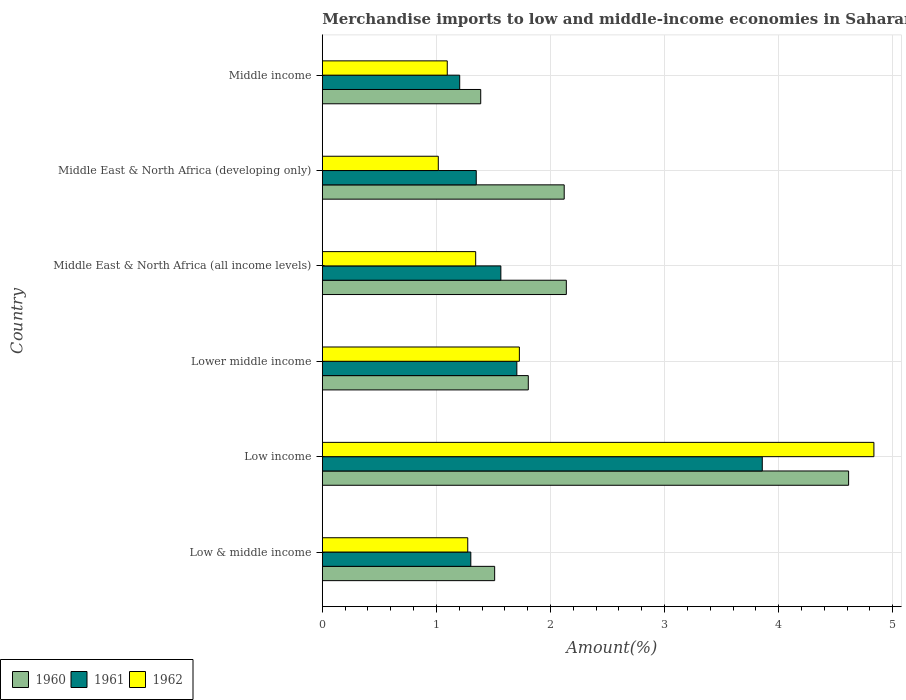How many different coloured bars are there?
Give a very brief answer. 3. Are the number of bars per tick equal to the number of legend labels?
Keep it short and to the point. Yes. Are the number of bars on each tick of the Y-axis equal?
Give a very brief answer. Yes. In how many cases, is the number of bars for a given country not equal to the number of legend labels?
Keep it short and to the point. 0. What is the percentage of amount earned from merchandise imports in 1961 in Middle East & North Africa (all income levels)?
Your answer should be compact. 1.57. Across all countries, what is the maximum percentage of amount earned from merchandise imports in 1962?
Keep it short and to the point. 4.84. Across all countries, what is the minimum percentage of amount earned from merchandise imports in 1962?
Offer a terse response. 1.02. What is the total percentage of amount earned from merchandise imports in 1962 in the graph?
Provide a short and direct response. 11.29. What is the difference between the percentage of amount earned from merchandise imports in 1962 in Middle East & North Africa (developing only) and that in Middle income?
Provide a short and direct response. -0.08. What is the difference between the percentage of amount earned from merchandise imports in 1962 in Low & middle income and the percentage of amount earned from merchandise imports in 1961 in Low income?
Keep it short and to the point. -2.58. What is the average percentage of amount earned from merchandise imports in 1962 per country?
Provide a succinct answer. 1.88. What is the difference between the percentage of amount earned from merchandise imports in 1961 and percentage of amount earned from merchandise imports in 1960 in Low & middle income?
Make the answer very short. -0.21. What is the ratio of the percentage of amount earned from merchandise imports in 1962 in Low income to that in Lower middle income?
Your response must be concise. 2.8. Is the percentage of amount earned from merchandise imports in 1960 in Middle East & North Africa (all income levels) less than that in Middle East & North Africa (developing only)?
Keep it short and to the point. No. Is the difference between the percentage of amount earned from merchandise imports in 1961 in Low & middle income and Low income greater than the difference between the percentage of amount earned from merchandise imports in 1960 in Low & middle income and Low income?
Offer a very short reply. Yes. What is the difference between the highest and the second highest percentage of amount earned from merchandise imports in 1962?
Provide a short and direct response. 3.11. What is the difference between the highest and the lowest percentage of amount earned from merchandise imports in 1962?
Your response must be concise. 3.82. What does the 3rd bar from the top in Middle East & North Africa (developing only) represents?
Give a very brief answer. 1960. What does the 2nd bar from the bottom in Middle East & North Africa (developing only) represents?
Your answer should be very brief. 1961. Is it the case that in every country, the sum of the percentage of amount earned from merchandise imports in 1962 and percentage of amount earned from merchandise imports in 1961 is greater than the percentage of amount earned from merchandise imports in 1960?
Your response must be concise. Yes. How many bars are there?
Keep it short and to the point. 18. Are all the bars in the graph horizontal?
Your answer should be compact. Yes. Does the graph contain grids?
Your answer should be compact. Yes. Where does the legend appear in the graph?
Give a very brief answer. Bottom left. How are the legend labels stacked?
Provide a short and direct response. Horizontal. What is the title of the graph?
Give a very brief answer. Merchandise imports to low and middle-income economies in Saharan Africa. Does "1999" appear as one of the legend labels in the graph?
Your answer should be compact. No. What is the label or title of the X-axis?
Give a very brief answer. Amount(%). What is the Amount(%) of 1960 in Low & middle income?
Your response must be concise. 1.51. What is the Amount(%) of 1961 in Low & middle income?
Your answer should be very brief. 1.3. What is the Amount(%) of 1962 in Low & middle income?
Offer a very short reply. 1.27. What is the Amount(%) in 1960 in Low income?
Offer a terse response. 4.61. What is the Amount(%) of 1961 in Low income?
Keep it short and to the point. 3.86. What is the Amount(%) in 1962 in Low income?
Provide a succinct answer. 4.84. What is the Amount(%) of 1960 in Lower middle income?
Your response must be concise. 1.81. What is the Amount(%) of 1961 in Lower middle income?
Keep it short and to the point. 1.71. What is the Amount(%) of 1962 in Lower middle income?
Your answer should be very brief. 1.73. What is the Amount(%) in 1960 in Middle East & North Africa (all income levels)?
Provide a short and direct response. 2.14. What is the Amount(%) in 1961 in Middle East & North Africa (all income levels)?
Make the answer very short. 1.57. What is the Amount(%) of 1962 in Middle East & North Africa (all income levels)?
Your answer should be compact. 1.34. What is the Amount(%) of 1960 in Middle East & North Africa (developing only)?
Give a very brief answer. 2.12. What is the Amount(%) in 1961 in Middle East & North Africa (developing only)?
Make the answer very short. 1.35. What is the Amount(%) of 1962 in Middle East & North Africa (developing only)?
Ensure brevity in your answer.  1.02. What is the Amount(%) of 1960 in Middle income?
Your response must be concise. 1.39. What is the Amount(%) in 1961 in Middle income?
Keep it short and to the point. 1.2. What is the Amount(%) in 1962 in Middle income?
Provide a short and direct response. 1.1. Across all countries, what is the maximum Amount(%) of 1960?
Offer a very short reply. 4.61. Across all countries, what is the maximum Amount(%) in 1961?
Make the answer very short. 3.86. Across all countries, what is the maximum Amount(%) in 1962?
Make the answer very short. 4.84. Across all countries, what is the minimum Amount(%) of 1960?
Keep it short and to the point. 1.39. Across all countries, what is the minimum Amount(%) of 1961?
Offer a terse response. 1.2. Across all countries, what is the minimum Amount(%) of 1962?
Give a very brief answer. 1.02. What is the total Amount(%) of 1960 in the graph?
Your answer should be compact. 13.58. What is the total Amount(%) of 1961 in the graph?
Your answer should be compact. 10.98. What is the total Amount(%) of 1962 in the graph?
Make the answer very short. 11.29. What is the difference between the Amount(%) of 1960 in Low & middle income and that in Low income?
Make the answer very short. -3.1. What is the difference between the Amount(%) of 1961 in Low & middle income and that in Low income?
Offer a terse response. -2.56. What is the difference between the Amount(%) of 1962 in Low & middle income and that in Low income?
Provide a succinct answer. -3.56. What is the difference between the Amount(%) in 1960 in Low & middle income and that in Lower middle income?
Keep it short and to the point. -0.29. What is the difference between the Amount(%) in 1961 in Low & middle income and that in Lower middle income?
Offer a terse response. -0.4. What is the difference between the Amount(%) of 1962 in Low & middle income and that in Lower middle income?
Give a very brief answer. -0.45. What is the difference between the Amount(%) in 1960 in Low & middle income and that in Middle East & North Africa (all income levels)?
Your answer should be very brief. -0.63. What is the difference between the Amount(%) in 1961 in Low & middle income and that in Middle East & North Africa (all income levels)?
Ensure brevity in your answer.  -0.26. What is the difference between the Amount(%) in 1962 in Low & middle income and that in Middle East & North Africa (all income levels)?
Provide a succinct answer. -0.07. What is the difference between the Amount(%) of 1960 in Low & middle income and that in Middle East & North Africa (developing only)?
Ensure brevity in your answer.  -0.61. What is the difference between the Amount(%) of 1961 in Low & middle income and that in Middle East & North Africa (developing only)?
Offer a terse response. -0.05. What is the difference between the Amount(%) of 1962 in Low & middle income and that in Middle East & North Africa (developing only)?
Provide a succinct answer. 0.26. What is the difference between the Amount(%) of 1960 in Low & middle income and that in Middle income?
Ensure brevity in your answer.  0.12. What is the difference between the Amount(%) of 1961 in Low & middle income and that in Middle income?
Give a very brief answer. 0.1. What is the difference between the Amount(%) of 1962 in Low & middle income and that in Middle income?
Keep it short and to the point. 0.18. What is the difference between the Amount(%) of 1960 in Low income and that in Lower middle income?
Offer a terse response. 2.81. What is the difference between the Amount(%) of 1961 in Low income and that in Lower middle income?
Offer a very short reply. 2.15. What is the difference between the Amount(%) in 1962 in Low income and that in Lower middle income?
Make the answer very short. 3.11. What is the difference between the Amount(%) in 1960 in Low income and that in Middle East & North Africa (all income levels)?
Provide a succinct answer. 2.47. What is the difference between the Amount(%) in 1961 in Low income and that in Middle East & North Africa (all income levels)?
Your answer should be very brief. 2.29. What is the difference between the Amount(%) of 1962 in Low income and that in Middle East & North Africa (all income levels)?
Your answer should be very brief. 3.49. What is the difference between the Amount(%) of 1960 in Low income and that in Middle East & North Africa (developing only)?
Your answer should be compact. 2.49. What is the difference between the Amount(%) of 1961 in Low income and that in Middle East & North Africa (developing only)?
Your response must be concise. 2.51. What is the difference between the Amount(%) of 1962 in Low income and that in Middle East & North Africa (developing only)?
Your response must be concise. 3.82. What is the difference between the Amount(%) in 1960 in Low income and that in Middle income?
Ensure brevity in your answer.  3.23. What is the difference between the Amount(%) in 1961 in Low income and that in Middle income?
Your answer should be compact. 2.65. What is the difference between the Amount(%) of 1962 in Low income and that in Middle income?
Give a very brief answer. 3.74. What is the difference between the Amount(%) of 1960 in Lower middle income and that in Middle East & North Africa (all income levels)?
Provide a short and direct response. -0.33. What is the difference between the Amount(%) in 1961 in Lower middle income and that in Middle East & North Africa (all income levels)?
Provide a succinct answer. 0.14. What is the difference between the Amount(%) of 1962 in Lower middle income and that in Middle East & North Africa (all income levels)?
Your answer should be compact. 0.38. What is the difference between the Amount(%) in 1960 in Lower middle income and that in Middle East & North Africa (developing only)?
Ensure brevity in your answer.  -0.31. What is the difference between the Amount(%) in 1961 in Lower middle income and that in Middle East & North Africa (developing only)?
Keep it short and to the point. 0.36. What is the difference between the Amount(%) of 1962 in Lower middle income and that in Middle East & North Africa (developing only)?
Keep it short and to the point. 0.71. What is the difference between the Amount(%) of 1960 in Lower middle income and that in Middle income?
Your answer should be compact. 0.42. What is the difference between the Amount(%) of 1961 in Lower middle income and that in Middle income?
Provide a short and direct response. 0.5. What is the difference between the Amount(%) of 1962 in Lower middle income and that in Middle income?
Give a very brief answer. 0.63. What is the difference between the Amount(%) of 1960 in Middle East & North Africa (all income levels) and that in Middle East & North Africa (developing only)?
Your answer should be very brief. 0.02. What is the difference between the Amount(%) in 1961 in Middle East & North Africa (all income levels) and that in Middle East & North Africa (developing only)?
Ensure brevity in your answer.  0.22. What is the difference between the Amount(%) of 1962 in Middle East & North Africa (all income levels) and that in Middle East & North Africa (developing only)?
Make the answer very short. 0.33. What is the difference between the Amount(%) in 1960 in Middle East & North Africa (all income levels) and that in Middle income?
Keep it short and to the point. 0.75. What is the difference between the Amount(%) in 1961 in Middle East & North Africa (all income levels) and that in Middle income?
Make the answer very short. 0.36. What is the difference between the Amount(%) in 1962 in Middle East & North Africa (all income levels) and that in Middle income?
Your answer should be compact. 0.25. What is the difference between the Amount(%) of 1960 in Middle East & North Africa (developing only) and that in Middle income?
Keep it short and to the point. 0.73. What is the difference between the Amount(%) in 1961 in Middle East & North Africa (developing only) and that in Middle income?
Ensure brevity in your answer.  0.15. What is the difference between the Amount(%) of 1962 in Middle East & North Africa (developing only) and that in Middle income?
Your answer should be compact. -0.08. What is the difference between the Amount(%) in 1960 in Low & middle income and the Amount(%) in 1961 in Low income?
Provide a succinct answer. -2.35. What is the difference between the Amount(%) in 1960 in Low & middle income and the Amount(%) in 1962 in Low income?
Offer a very short reply. -3.32. What is the difference between the Amount(%) of 1961 in Low & middle income and the Amount(%) of 1962 in Low income?
Offer a terse response. -3.53. What is the difference between the Amount(%) of 1960 in Low & middle income and the Amount(%) of 1961 in Lower middle income?
Give a very brief answer. -0.19. What is the difference between the Amount(%) of 1960 in Low & middle income and the Amount(%) of 1962 in Lower middle income?
Give a very brief answer. -0.22. What is the difference between the Amount(%) of 1961 in Low & middle income and the Amount(%) of 1962 in Lower middle income?
Your answer should be very brief. -0.43. What is the difference between the Amount(%) in 1960 in Low & middle income and the Amount(%) in 1961 in Middle East & North Africa (all income levels)?
Provide a short and direct response. -0.05. What is the difference between the Amount(%) in 1960 in Low & middle income and the Amount(%) in 1962 in Middle East & North Africa (all income levels)?
Keep it short and to the point. 0.17. What is the difference between the Amount(%) in 1961 in Low & middle income and the Amount(%) in 1962 in Middle East & North Africa (all income levels)?
Offer a terse response. -0.04. What is the difference between the Amount(%) of 1960 in Low & middle income and the Amount(%) of 1961 in Middle East & North Africa (developing only)?
Provide a succinct answer. 0.16. What is the difference between the Amount(%) in 1960 in Low & middle income and the Amount(%) in 1962 in Middle East & North Africa (developing only)?
Make the answer very short. 0.49. What is the difference between the Amount(%) of 1961 in Low & middle income and the Amount(%) of 1962 in Middle East & North Africa (developing only)?
Offer a terse response. 0.29. What is the difference between the Amount(%) in 1960 in Low & middle income and the Amount(%) in 1961 in Middle income?
Keep it short and to the point. 0.31. What is the difference between the Amount(%) of 1960 in Low & middle income and the Amount(%) of 1962 in Middle income?
Your answer should be very brief. 0.42. What is the difference between the Amount(%) of 1961 in Low & middle income and the Amount(%) of 1962 in Middle income?
Your answer should be compact. 0.21. What is the difference between the Amount(%) in 1960 in Low income and the Amount(%) in 1961 in Lower middle income?
Ensure brevity in your answer.  2.91. What is the difference between the Amount(%) in 1960 in Low income and the Amount(%) in 1962 in Lower middle income?
Provide a succinct answer. 2.89. What is the difference between the Amount(%) in 1961 in Low income and the Amount(%) in 1962 in Lower middle income?
Your response must be concise. 2.13. What is the difference between the Amount(%) of 1960 in Low income and the Amount(%) of 1961 in Middle East & North Africa (all income levels)?
Ensure brevity in your answer.  3.05. What is the difference between the Amount(%) in 1960 in Low income and the Amount(%) in 1962 in Middle East & North Africa (all income levels)?
Offer a very short reply. 3.27. What is the difference between the Amount(%) of 1961 in Low income and the Amount(%) of 1962 in Middle East & North Africa (all income levels)?
Ensure brevity in your answer.  2.51. What is the difference between the Amount(%) in 1960 in Low income and the Amount(%) in 1961 in Middle East & North Africa (developing only)?
Provide a short and direct response. 3.26. What is the difference between the Amount(%) of 1960 in Low income and the Amount(%) of 1962 in Middle East & North Africa (developing only)?
Keep it short and to the point. 3.6. What is the difference between the Amount(%) in 1961 in Low income and the Amount(%) in 1962 in Middle East & North Africa (developing only)?
Provide a short and direct response. 2.84. What is the difference between the Amount(%) in 1960 in Low income and the Amount(%) in 1961 in Middle income?
Your response must be concise. 3.41. What is the difference between the Amount(%) of 1960 in Low income and the Amount(%) of 1962 in Middle income?
Provide a short and direct response. 3.52. What is the difference between the Amount(%) of 1961 in Low income and the Amount(%) of 1962 in Middle income?
Offer a very short reply. 2.76. What is the difference between the Amount(%) of 1960 in Lower middle income and the Amount(%) of 1961 in Middle East & North Africa (all income levels)?
Offer a terse response. 0.24. What is the difference between the Amount(%) of 1960 in Lower middle income and the Amount(%) of 1962 in Middle East & North Africa (all income levels)?
Keep it short and to the point. 0.46. What is the difference between the Amount(%) of 1961 in Lower middle income and the Amount(%) of 1962 in Middle East & North Africa (all income levels)?
Ensure brevity in your answer.  0.36. What is the difference between the Amount(%) in 1960 in Lower middle income and the Amount(%) in 1961 in Middle East & North Africa (developing only)?
Provide a succinct answer. 0.46. What is the difference between the Amount(%) in 1960 in Lower middle income and the Amount(%) in 1962 in Middle East & North Africa (developing only)?
Provide a succinct answer. 0.79. What is the difference between the Amount(%) of 1961 in Lower middle income and the Amount(%) of 1962 in Middle East & North Africa (developing only)?
Offer a very short reply. 0.69. What is the difference between the Amount(%) of 1960 in Lower middle income and the Amount(%) of 1961 in Middle income?
Give a very brief answer. 0.6. What is the difference between the Amount(%) in 1960 in Lower middle income and the Amount(%) in 1962 in Middle income?
Provide a short and direct response. 0.71. What is the difference between the Amount(%) of 1961 in Lower middle income and the Amount(%) of 1962 in Middle income?
Offer a very short reply. 0.61. What is the difference between the Amount(%) in 1960 in Middle East & North Africa (all income levels) and the Amount(%) in 1961 in Middle East & North Africa (developing only)?
Give a very brief answer. 0.79. What is the difference between the Amount(%) of 1960 in Middle East & North Africa (all income levels) and the Amount(%) of 1962 in Middle East & North Africa (developing only)?
Your answer should be very brief. 1.12. What is the difference between the Amount(%) in 1961 in Middle East & North Africa (all income levels) and the Amount(%) in 1962 in Middle East & North Africa (developing only)?
Offer a very short reply. 0.55. What is the difference between the Amount(%) of 1960 in Middle East & North Africa (all income levels) and the Amount(%) of 1961 in Middle income?
Your response must be concise. 0.93. What is the difference between the Amount(%) of 1960 in Middle East & North Africa (all income levels) and the Amount(%) of 1962 in Middle income?
Your answer should be compact. 1.04. What is the difference between the Amount(%) in 1961 in Middle East & North Africa (all income levels) and the Amount(%) in 1962 in Middle income?
Your answer should be very brief. 0.47. What is the difference between the Amount(%) of 1960 in Middle East & North Africa (developing only) and the Amount(%) of 1961 in Middle income?
Ensure brevity in your answer.  0.92. What is the difference between the Amount(%) in 1960 in Middle East & North Africa (developing only) and the Amount(%) in 1962 in Middle income?
Ensure brevity in your answer.  1.03. What is the difference between the Amount(%) of 1961 in Middle East & North Africa (developing only) and the Amount(%) of 1962 in Middle income?
Provide a succinct answer. 0.25. What is the average Amount(%) in 1960 per country?
Give a very brief answer. 2.26. What is the average Amount(%) in 1961 per country?
Provide a short and direct response. 1.83. What is the average Amount(%) in 1962 per country?
Offer a very short reply. 1.88. What is the difference between the Amount(%) in 1960 and Amount(%) in 1961 in Low & middle income?
Make the answer very short. 0.21. What is the difference between the Amount(%) in 1960 and Amount(%) in 1962 in Low & middle income?
Your answer should be very brief. 0.24. What is the difference between the Amount(%) in 1961 and Amount(%) in 1962 in Low & middle income?
Your answer should be compact. 0.03. What is the difference between the Amount(%) in 1960 and Amount(%) in 1961 in Low income?
Make the answer very short. 0.76. What is the difference between the Amount(%) of 1960 and Amount(%) of 1962 in Low income?
Ensure brevity in your answer.  -0.22. What is the difference between the Amount(%) of 1961 and Amount(%) of 1962 in Low income?
Make the answer very short. -0.98. What is the difference between the Amount(%) of 1960 and Amount(%) of 1961 in Lower middle income?
Make the answer very short. 0.1. What is the difference between the Amount(%) of 1960 and Amount(%) of 1962 in Lower middle income?
Your response must be concise. 0.08. What is the difference between the Amount(%) of 1961 and Amount(%) of 1962 in Lower middle income?
Ensure brevity in your answer.  -0.02. What is the difference between the Amount(%) of 1960 and Amount(%) of 1961 in Middle East & North Africa (all income levels)?
Give a very brief answer. 0.57. What is the difference between the Amount(%) in 1960 and Amount(%) in 1962 in Middle East & North Africa (all income levels)?
Provide a short and direct response. 0.79. What is the difference between the Amount(%) in 1961 and Amount(%) in 1962 in Middle East & North Africa (all income levels)?
Give a very brief answer. 0.22. What is the difference between the Amount(%) of 1960 and Amount(%) of 1961 in Middle East & North Africa (developing only)?
Provide a short and direct response. 0.77. What is the difference between the Amount(%) in 1960 and Amount(%) in 1962 in Middle East & North Africa (developing only)?
Your answer should be compact. 1.1. What is the difference between the Amount(%) of 1961 and Amount(%) of 1962 in Middle East & North Africa (developing only)?
Give a very brief answer. 0.33. What is the difference between the Amount(%) in 1960 and Amount(%) in 1961 in Middle income?
Your answer should be compact. 0.18. What is the difference between the Amount(%) of 1960 and Amount(%) of 1962 in Middle income?
Provide a succinct answer. 0.29. What is the difference between the Amount(%) of 1961 and Amount(%) of 1962 in Middle income?
Offer a terse response. 0.11. What is the ratio of the Amount(%) in 1960 in Low & middle income to that in Low income?
Keep it short and to the point. 0.33. What is the ratio of the Amount(%) in 1961 in Low & middle income to that in Low income?
Your answer should be compact. 0.34. What is the ratio of the Amount(%) in 1962 in Low & middle income to that in Low income?
Make the answer very short. 0.26. What is the ratio of the Amount(%) in 1960 in Low & middle income to that in Lower middle income?
Your response must be concise. 0.84. What is the ratio of the Amount(%) of 1961 in Low & middle income to that in Lower middle income?
Ensure brevity in your answer.  0.76. What is the ratio of the Amount(%) of 1962 in Low & middle income to that in Lower middle income?
Your answer should be very brief. 0.74. What is the ratio of the Amount(%) of 1960 in Low & middle income to that in Middle East & North Africa (all income levels)?
Your answer should be compact. 0.71. What is the ratio of the Amount(%) of 1961 in Low & middle income to that in Middle East & North Africa (all income levels)?
Offer a terse response. 0.83. What is the ratio of the Amount(%) in 1962 in Low & middle income to that in Middle East & North Africa (all income levels)?
Ensure brevity in your answer.  0.95. What is the ratio of the Amount(%) of 1960 in Low & middle income to that in Middle East & North Africa (developing only)?
Provide a succinct answer. 0.71. What is the ratio of the Amount(%) in 1961 in Low & middle income to that in Middle East & North Africa (developing only)?
Ensure brevity in your answer.  0.96. What is the ratio of the Amount(%) in 1962 in Low & middle income to that in Middle East & North Africa (developing only)?
Your answer should be very brief. 1.25. What is the ratio of the Amount(%) in 1960 in Low & middle income to that in Middle income?
Your response must be concise. 1.09. What is the ratio of the Amount(%) of 1961 in Low & middle income to that in Middle income?
Your answer should be compact. 1.08. What is the ratio of the Amount(%) of 1962 in Low & middle income to that in Middle income?
Your answer should be very brief. 1.16. What is the ratio of the Amount(%) of 1960 in Low income to that in Lower middle income?
Provide a succinct answer. 2.56. What is the ratio of the Amount(%) of 1961 in Low income to that in Lower middle income?
Your response must be concise. 2.26. What is the ratio of the Amount(%) in 1962 in Low income to that in Lower middle income?
Give a very brief answer. 2.8. What is the ratio of the Amount(%) of 1960 in Low income to that in Middle East & North Africa (all income levels)?
Your response must be concise. 2.16. What is the ratio of the Amount(%) of 1961 in Low income to that in Middle East & North Africa (all income levels)?
Your answer should be very brief. 2.46. What is the ratio of the Amount(%) of 1962 in Low income to that in Middle East & North Africa (all income levels)?
Offer a terse response. 3.6. What is the ratio of the Amount(%) in 1960 in Low income to that in Middle East & North Africa (developing only)?
Make the answer very short. 2.18. What is the ratio of the Amount(%) of 1961 in Low income to that in Middle East & North Africa (developing only)?
Keep it short and to the point. 2.86. What is the ratio of the Amount(%) of 1962 in Low income to that in Middle East & North Africa (developing only)?
Make the answer very short. 4.76. What is the ratio of the Amount(%) of 1960 in Low income to that in Middle income?
Ensure brevity in your answer.  3.32. What is the ratio of the Amount(%) in 1961 in Low income to that in Middle income?
Offer a very short reply. 3.2. What is the ratio of the Amount(%) of 1962 in Low income to that in Middle income?
Offer a terse response. 4.42. What is the ratio of the Amount(%) of 1960 in Lower middle income to that in Middle East & North Africa (all income levels)?
Offer a terse response. 0.84. What is the ratio of the Amount(%) in 1961 in Lower middle income to that in Middle East & North Africa (all income levels)?
Your answer should be compact. 1.09. What is the ratio of the Amount(%) in 1962 in Lower middle income to that in Middle East & North Africa (all income levels)?
Offer a terse response. 1.28. What is the ratio of the Amount(%) of 1960 in Lower middle income to that in Middle East & North Africa (developing only)?
Ensure brevity in your answer.  0.85. What is the ratio of the Amount(%) in 1961 in Lower middle income to that in Middle East & North Africa (developing only)?
Make the answer very short. 1.26. What is the ratio of the Amount(%) in 1962 in Lower middle income to that in Middle East & North Africa (developing only)?
Offer a very short reply. 1.7. What is the ratio of the Amount(%) in 1960 in Lower middle income to that in Middle income?
Provide a succinct answer. 1.3. What is the ratio of the Amount(%) in 1961 in Lower middle income to that in Middle income?
Give a very brief answer. 1.42. What is the ratio of the Amount(%) of 1962 in Lower middle income to that in Middle income?
Offer a very short reply. 1.58. What is the ratio of the Amount(%) of 1960 in Middle East & North Africa (all income levels) to that in Middle East & North Africa (developing only)?
Provide a succinct answer. 1.01. What is the ratio of the Amount(%) of 1961 in Middle East & North Africa (all income levels) to that in Middle East & North Africa (developing only)?
Make the answer very short. 1.16. What is the ratio of the Amount(%) in 1962 in Middle East & North Africa (all income levels) to that in Middle East & North Africa (developing only)?
Give a very brief answer. 1.32. What is the ratio of the Amount(%) of 1960 in Middle East & North Africa (all income levels) to that in Middle income?
Provide a short and direct response. 1.54. What is the ratio of the Amount(%) of 1961 in Middle East & North Africa (all income levels) to that in Middle income?
Give a very brief answer. 1.3. What is the ratio of the Amount(%) of 1962 in Middle East & North Africa (all income levels) to that in Middle income?
Provide a short and direct response. 1.23. What is the ratio of the Amount(%) of 1960 in Middle East & North Africa (developing only) to that in Middle income?
Provide a succinct answer. 1.53. What is the ratio of the Amount(%) of 1961 in Middle East & North Africa (developing only) to that in Middle income?
Offer a terse response. 1.12. What is the ratio of the Amount(%) of 1962 in Middle East & North Africa (developing only) to that in Middle income?
Offer a very short reply. 0.93. What is the difference between the highest and the second highest Amount(%) in 1960?
Your answer should be compact. 2.47. What is the difference between the highest and the second highest Amount(%) in 1961?
Make the answer very short. 2.15. What is the difference between the highest and the second highest Amount(%) of 1962?
Your answer should be compact. 3.11. What is the difference between the highest and the lowest Amount(%) of 1960?
Provide a succinct answer. 3.23. What is the difference between the highest and the lowest Amount(%) of 1961?
Keep it short and to the point. 2.65. What is the difference between the highest and the lowest Amount(%) in 1962?
Offer a terse response. 3.82. 